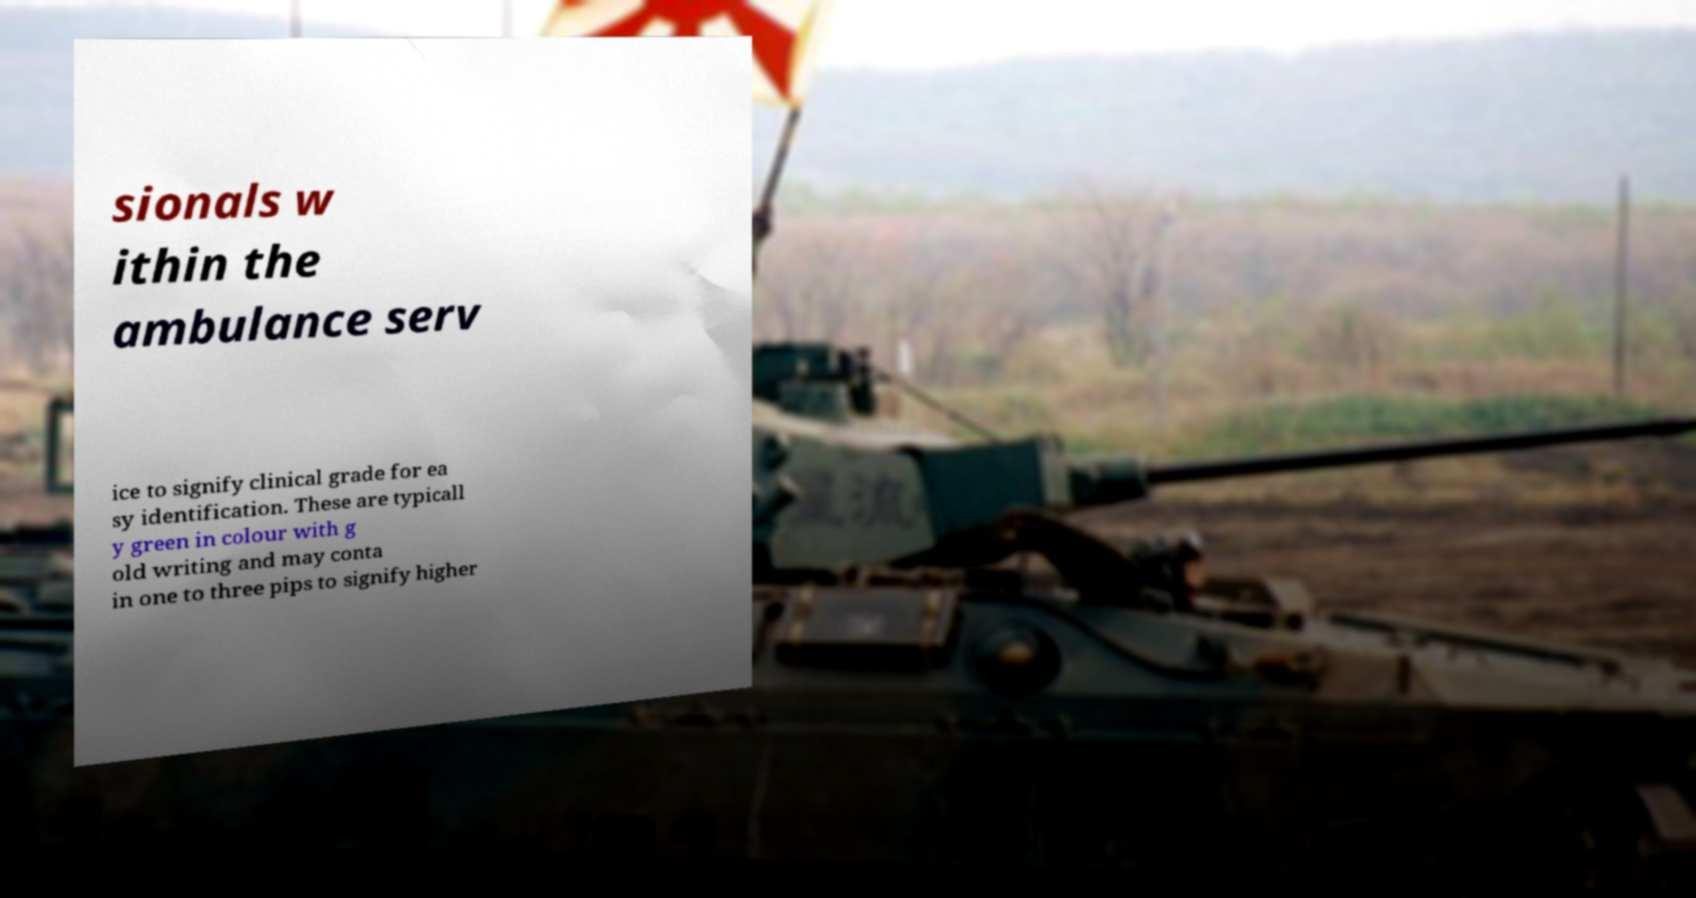Can you accurately transcribe the text from the provided image for me? sionals w ithin the ambulance serv ice to signify clinical grade for ea sy identification. These are typicall y green in colour with g old writing and may conta in one to three pips to signify higher 